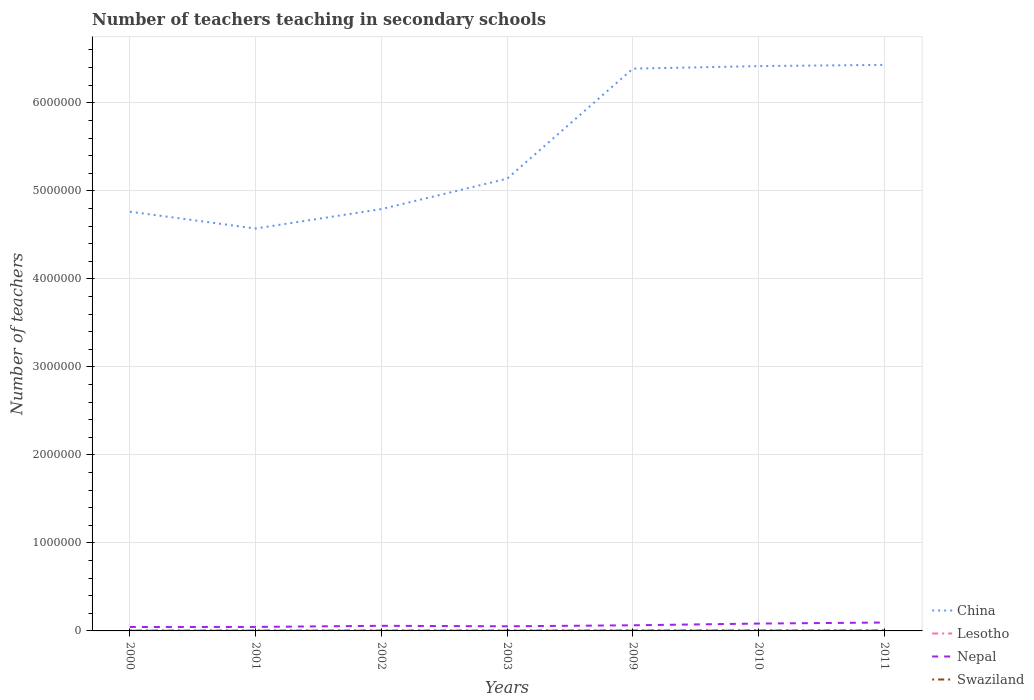How many different coloured lines are there?
Ensure brevity in your answer.  4. Across all years, what is the maximum number of teachers teaching in secondary schools in Lesotho?
Offer a very short reply. 3368. In which year was the number of teachers teaching in secondary schools in Swaziland maximum?
Keep it short and to the point. 2000. What is the total number of teachers teaching in secondary schools in Swaziland in the graph?
Make the answer very short. -1045. What is the difference between the highest and the second highest number of teachers teaching in secondary schools in China?
Your response must be concise. 1.86e+06. Is the number of teachers teaching in secondary schools in Lesotho strictly greater than the number of teachers teaching in secondary schools in China over the years?
Your answer should be very brief. Yes. What is the difference between two consecutive major ticks on the Y-axis?
Keep it short and to the point. 1.00e+06. Are the values on the major ticks of Y-axis written in scientific E-notation?
Give a very brief answer. No. Does the graph contain any zero values?
Keep it short and to the point. No. Where does the legend appear in the graph?
Your answer should be very brief. Bottom right. How many legend labels are there?
Offer a very short reply. 4. What is the title of the graph?
Make the answer very short. Number of teachers teaching in secondary schools. What is the label or title of the Y-axis?
Your response must be concise. Number of teachers. What is the Number of teachers in China in 2000?
Your answer should be compact. 4.76e+06. What is the Number of teachers of Lesotho in 2000?
Your answer should be very brief. 3368. What is the Number of teachers of Nepal in 2000?
Your response must be concise. 4.46e+04. What is the Number of teachers in Swaziland in 2000?
Ensure brevity in your answer.  3487. What is the Number of teachers in China in 2001?
Provide a short and direct response. 4.57e+06. What is the Number of teachers in Lesotho in 2001?
Provide a short and direct response. 3455. What is the Number of teachers in Nepal in 2001?
Provide a short and direct response. 4.54e+04. What is the Number of teachers of Swaziland in 2001?
Give a very brief answer. 3647. What is the Number of teachers in China in 2002?
Keep it short and to the point. 4.79e+06. What is the Number of teachers of Lesotho in 2002?
Your answer should be very brief. 3546. What is the Number of teachers of Nepal in 2002?
Make the answer very short. 5.82e+04. What is the Number of teachers of Swaziland in 2002?
Your answer should be compact. 3845. What is the Number of teachers of China in 2003?
Provide a succinct answer. 5.14e+06. What is the Number of teachers in Lesotho in 2003?
Give a very brief answer. 3636. What is the Number of teachers in Nepal in 2003?
Make the answer very short. 5.25e+04. What is the Number of teachers in Swaziland in 2003?
Ensure brevity in your answer.  3684. What is the Number of teachers of China in 2009?
Provide a short and direct response. 6.39e+06. What is the Number of teachers in Lesotho in 2009?
Ensure brevity in your answer.  4962. What is the Number of teachers of Nepal in 2009?
Provide a succinct answer. 6.40e+04. What is the Number of teachers in Swaziland in 2009?
Your answer should be compact. 4717. What is the Number of teachers of China in 2010?
Ensure brevity in your answer.  6.42e+06. What is the Number of teachers of Lesotho in 2010?
Ensure brevity in your answer.  5139. What is the Number of teachers in Nepal in 2010?
Keep it short and to the point. 8.36e+04. What is the Number of teachers in Swaziland in 2010?
Ensure brevity in your answer.  4890. What is the Number of teachers of China in 2011?
Ensure brevity in your answer.  6.43e+06. What is the Number of teachers in Lesotho in 2011?
Your answer should be compact. 5282. What is the Number of teachers of Nepal in 2011?
Offer a very short reply. 9.53e+04. What is the Number of teachers of Swaziland in 2011?
Offer a terse response. 5250. Across all years, what is the maximum Number of teachers in China?
Offer a very short reply. 6.43e+06. Across all years, what is the maximum Number of teachers of Lesotho?
Keep it short and to the point. 5282. Across all years, what is the maximum Number of teachers in Nepal?
Offer a very short reply. 9.53e+04. Across all years, what is the maximum Number of teachers in Swaziland?
Ensure brevity in your answer.  5250. Across all years, what is the minimum Number of teachers of China?
Provide a succinct answer. 4.57e+06. Across all years, what is the minimum Number of teachers of Lesotho?
Ensure brevity in your answer.  3368. Across all years, what is the minimum Number of teachers of Nepal?
Keep it short and to the point. 4.46e+04. Across all years, what is the minimum Number of teachers in Swaziland?
Ensure brevity in your answer.  3487. What is the total Number of teachers of China in the graph?
Offer a very short reply. 3.85e+07. What is the total Number of teachers in Lesotho in the graph?
Offer a terse response. 2.94e+04. What is the total Number of teachers of Nepal in the graph?
Offer a very short reply. 4.44e+05. What is the total Number of teachers in Swaziland in the graph?
Your answer should be compact. 2.95e+04. What is the difference between the Number of teachers in China in 2000 and that in 2001?
Offer a very short reply. 1.91e+05. What is the difference between the Number of teachers in Lesotho in 2000 and that in 2001?
Provide a short and direct response. -87. What is the difference between the Number of teachers of Nepal in 2000 and that in 2001?
Offer a terse response. -753. What is the difference between the Number of teachers of Swaziland in 2000 and that in 2001?
Offer a very short reply. -160. What is the difference between the Number of teachers in China in 2000 and that in 2002?
Offer a terse response. -2.98e+04. What is the difference between the Number of teachers in Lesotho in 2000 and that in 2002?
Keep it short and to the point. -178. What is the difference between the Number of teachers in Nepal in 2000 and that in 2002?
Offer a terse response. -1.36e+04. What is the difference between the Number of teachers of Swaziland in 2000 and that in 2002?
Ensure brevity in your answer.  -358. What is the difference between the Number of teachers of China in 2000 and that in 2003?
Your response must be concise. -3.75e+05. What is the difference between the Number of teachers in Lesotho in 2000 and that in 2003?
Your answer should be very brief. -268. What is the difference between the Number of teachers of Nepal in 2000 and that in 2003?
Keep it short and to the point. -7908. What is the difference between the Number of teachers in Swaziland in 2000 and that in 2003?
Provide a succinct answer. -197. What is the difference between the Number of teachers in China in 2000 and that in 2009?
Give a very brief answer. -1.63e+06. What is the difference between the Number of teachers in Lesotho in 2000 and that in 2009?
Your response must be concise. -1594. What is the difference between the Number of teachers of Nepal in 2000 and that in 2009?
Offer a terse response. -1.94e+04. What is the difference between the Number of teachers of Swaziland in 2000 and that in 2009?
Make the answer very short. -1230. What is the difference between the Number of teachers of China in 2000 and that in 2010?
Keep it short and to the point. -1.65e+06. What is the difference between the Number of teachers of Lesotho in 2000 and that in 2010?
Offer a very short reply. -1771. What is the difference between the Number of teachers in Nepal in 2000 and that in 2010?
Make the answer very short. -3.90e+04. What is the difference between the Number of teachers in Swaziland in 2000 and that in 2010?
Keep it short and to the point. -1403. What is the difference between the Number of teachers in China in 2000 and that in 2011?
Your answer should be compact. -1.67e+06. What is the difference between the Number of teachers in Lesotho in 2000 and that in 2011?
Keep it short and to the point. -1914. What is the difference between the Number of teachers in Nepal in 2000 and that in 2011?
Offer a terse response. -5.07e+04. What is the difference between the Number of teachers of Swaziland in 2000 and that in 2011?
Give a very brief answer. -1763. What is the difference between the Number of teachers in China in 2001 and that in 2002?
Provide a short and direct response. -2.21e+05. What is the difference between the Number of teachers in Lesotho in 2001 and that in 2002?
Your answer should be compact. -91. What is the difference between the Number of teachers of Nepal in 2001 and that in 2002?
Provide a short and direct response. -1.28e+04. What is the difference between the Number of teachers in Swaziland in 2001 and that in 2002?
Provide a short and direct response. -198. What is the difference between the Number of teachers in China in 2001 and that in 2003?
Ensure brevity in your answer.  -5.66e+05. What is the difference between the Number of teachers of Lesotho in 2001 and that in 2003?
Offer a very short reply. -181. What is the difference between the Number of teachers of Nepal in 2001 and that in 2003?
Your response must be concise. -7155. What is the difference between the Number of teachers of Swaziland in 2001 and that in 2003?
Your response must be concise. -37. What is the difference between the Number of teachers in China in 2001 and that in 2009?
Ensure brevity in your answer.  -1.82e+06. What is the difference between the Number of teachers in Lesotho in 2001 and that in 2009?
Your answer should be compact. -1507. What is the difference between the Number of teachers in Nepal in 2001 and that in 2009?
Make the answer very short. -1.86e+04. What is the difference between the Number of teachers in Swaziland in 2001 and that in 2009?
Provide a succinct answer. -1070. What is the difference between the Number of teachers of China in 2001 and that in 2010?
Your answer should be very brief. -1.84e+06. What is the difference between the Number of teachers of Lesotho in 2001 and that in 2010?
Provide a succinct answer. -1684. What is the difference between the Number of teachers in Nepal in 2001 and that in 2010?
Ensure brevity in your answer.  -3.83e+04. What is the difference between the Number of teachers of Swaziland in 2001 and that in 2010?
Your answer should be compact. -1243. What is the difference between the Number of teachers in China in 2001 and that in 2011?
Give a very brief answer. -1.86e+06. What is the difference between the Number of teachers in Lesotho in 2001 and that in 2011?
Provide a succinct answer. -1827. What is the difference between the Number of teachers in Nepal in 2001 and that in 2011?
Ensure brevity in your answer.  -4.99e+04. What is the difference between the Number of teachers in Swaziland in 2001 and that in 2011?
Your answer should be compact. -1603. What is the difference between the Number of teachers of China in 2002 and that in 2003?
Your response must be concise. -3.45e+05. What is the difference between the Number of teachers of Lesotho in 2002 and that in 2003?
Ensure brevity in your answer.  -90. What is the difference between the Number of teachers of Nepal in 2002 and that in 2003?
Make the answer very short. 5662. What is the difference between the Number of teachers of Swaziland in 2002 and that in 2003?
Offer a very short reply. 161. What is the difference between the Number of teachers in China in 2002 and that in 2009?
Offer a terse response. -1.60e+06. What is the difference between the Number of teachers of Lesotho in 2002 and that in 2009?
Keep it short and to the point. -1416. What is the difference between the Number of teachers of Nepal in 2002 and that in 2009?
Offer a very short reply. -5803. What is the difference between the Number of teachers in Swaziland in 2002 and that in 2009?
Keep it short and to the point. -872. What is the difference between the Number of teachers in China in 2002 and that in 2010?
Your response must be concise. -1.62e+06. What is the difference between the Number of teachers of Lesotho in 2002 and that in 2010?
Provide a succinct answer. -1593. What is the difference between the Number of teachers of Nepal in 2002 and that in 2010?
Ensure brevity in your answer.  -2.54e+04. What is the difference between the Number of teachers of Swaziland in 2002 and that in 2010?
Your answer should be very brief. -1045. What is the difference between the Number of teachers in China in 2002 and that in 2011?
Make the answer very short. -1.64e+06. What is the difference between the Number of teachers of Lesotho in 2002 and that in 2011?
Ensure brevity in your answer.  -1736. What is the difference between the Number of teachers in Nepal in 2002 and that in 2011?
Give a very brief answer. -3.71e+04. What is the difference between the Number of teachers in Swaziland in 2002 and that in 2011?
Ensure brevity in your answer.  -1405. What is the difference between the Number of teachers in China in 2003 and that in 2009?
Your answer should be compact. -1.25e+06. What is the difference between the Number of teachers in Lesotho in 2003 and that in 2009?
Your answer should be compact. -1326. What is the difference between the Number of teachers in Nepal in 2003 and that in 2009?
Offer a terse response. -1.15e+04. What is the difference between the Number of teachers in Swaziland in 2003 and that in 2009?
Offer a terse response. -1033. What is the difference between the Number of teachers in China in 2003 and that in 2010?
Provide a short and direct response. -1.28e+06. What is the difference between the Number of teachers of Lesotho in 2003 and that in 2010?
Keep it short and to the point. -1503. What is the difference between the Number of teachers of Nepal in 2003 and that in 2010?
Keep it short and to the point. -3.11e+04. What is the difference between the Number of teachers of Swaziland in 2003 and that in 2010?
Make the answer very short. -1206. What is the difference between the Number of teachers of China in 2003 and that in 2011?
Your response must be concise. -1.29e+06. What is the difference between the Number of teachers of Lesotho in 2003 and that in 2011?
Provide a short and direct response. -1646. What is the difference between the Number of teachers of Nepal in 2003 and that in 2011?
Provide a short and direct response. -4.28e+04. What is the difference between the Number of teachers in Swaziland in 2003 and that in 2011?
Ensure brevity in your answer.  -1566. What is the difference between the Number of teachers in China in 2009 and that in 2010?
Make the answer very short. -2.87e+04. What is the difference between the Number of teachers in Lesotho in 2009 and that in 2010?
Make the answer very short. -177. What is the difference between the Number of teachers in Nepal in 2009 and that in 2010?
Provide a short and direct response. -1.96e+04. What is the difference between the Number of teachers of Swaziland in 2009 and that in 2010?
Provide a succinct answer. -173. What is the difference between the Number of teachers of China in 2009 and that in 2011?
Give a very brief answer. -4.28e+04. What is the difference between the Number of teachers in Lesotho in 2009 and that in 2011?
Offer a very short reply. -320. What is the difference between the Number of teachers in Nepal in 2009 and that in 2011?
Provide a short and direct response. -3.13e+04. What is the difference between the Number of teachers in Swaziland in 2009 and that in 2011?
Ensure brevity in your answer.  -533. What is the difference between the Number of teachers in China in 2010 and that in 2011?
Your response must be concise. -1.41e+04. What is the difference between the Number of teachers of Lesotho in 2010 and that in 2011?
Your answer should be compact. -143. What is the difference between the Number of teachers of Nepal in 2010 and that in 2011?
Offer a very short reply. -1.17e+04. What is the difference between the Number of teachers in Swaziland in 2010 and that in 2011?
Your answer should be very brief. -360. What is the difference between the Number of teachers of China in 2000 and the Number of teachers of Lesotho in 2001?
Make the answer very short. 4.76e+06. What is the difference between the Number of teachers in China in 2000 and the Number of teachers in Nepal in 2001?
Provide a short and direct response. 4.72e+06. What is the difference between the Number of teachers in China in 2000 and the Number of teachers in Swaziland in 2001?
Your answer should be very brief. 4.76e+06. What is the difference between the Number of teachers in Lesotho in 2000 and the Number of teachers in Nepal in 2001?
Ensure brevity in your answer.  -4.20e+04. What is the difference between the Number of teachers of Lesotho in 2000 and the Number of teachers of Swaziland in 2001?
Ensure brevity in your answer.  -279. What is the difference between the Number of teachers of Nepal in 2000 and the Number of teachers of Swaziland in 2001?
Make the answer very short. 4.10e+04. What is the difference between the Number of teachers of China in 2000 and the Number of teachers of Lesotho in 2002?
Make the answer very short. 4.76e+06. What is the difference between the Number of teachers in China in 2000 and the Number of teachers in Nepal in 2002?
Offer a terse response. 4.70e+06. What is the difference between the Number of teachers in China in 2000 and the Number of teachers in Swaziland in 2002?
Ensure brevity in your answer.  4.76e+06. What is the difference between the Number of teachers of Lesotho in 2000 and the Number of teachers of Nepal in 2002?
Make the answer very short. -5.48e+04. What is the difference between the Number of teachers of Lesotho in 2000 and the Number of teachers of Swaziland in 2002?
Provide a succinct answer. -477. What is the difference between the Number of teachers in Nepal in 2000 and the Number of teachers in Swaziland in 2002?
Offer a terse response. 4.08e+04. What is the difference between the Number of teachers of China in 2000 and the Number of teachers of Lesotho in 2003?
Your response must be concise. 4.76e+06. What is the difference between the Number of teachers in China in 2000 and the Number of teachers in Nepal in 2003?
Provide a short and direct response. 4.71e+06. What is the difference between the Number of teachers of China in 2000 and the Number of teachers of Swaziland in 2003?
Your response must be concise. 4.76e+06. What is the difference between the Number of teachers in Lesotho in 2000 and the Number of teachers in Nepal in 2003?
Provide a short and direct response. -4.92e+04. What is the difference between the Number of teachers in Lesotho in 2000 and the Number of teachers in Swaziland in 2003?
Keep it short and to the point. -316. What is the difference between the Number of teachers of Nepal in 2000 and the Number of teachers of Swaziland in 2003?
Make the answer very short. 4.09e+04. What is the difference between the Number of teachers of China in 2000 and the Number of teachers of Lesotho in 2009?
Make the answer very short. 4.76e+06. What is the difference between the Number of teachers of China in 2000 and the Number of teachers of Nepal in 2009?
Provide a short and direct response. 4.70e+06. What is the difference between the Number of teachers in China in 2000 and the Number of teachers in Swaziland in 2009?
Keep it short and to the point. 4.76e+06. What is the difference between the Number of teachers of Lesotho in 2000 and the Number of teachers of Nepal in 2009?
Your answer should be very brief. -6.06e+04. What is the difference between the Number of teachers in Lesotho in 2000 and the Number of teachers in Swaziland in 2009?
Your answer should be compact. -1349. What is the difference between the Number of teachers of Nepal in 2000 and the Number of teachers of Swaziland in 2009?
Give a very brief answer. 3.99e+04. What is the difference between the Number of teachers of China in 2000 and the Number of teachers of Lesotho in 2010?
Provide a short and direct response. 4.76e+06. What is the difference between the Number of teachers of China in 2000 and the Number of teachers of Nepal in 2010?
Provide a short and direct response. 4.68e+06. What is the difference between the Number of teachers in China in 2000 and the Number of teachers in Swaziland in 2010?
Provide a short and direct response. 4.76e+06. What is the difference between the Number of teachers of Lesotho in 2000 and the Number of teachers of Nepal in 2010?
Your answer should be very brief. -8.03e+04. What is the difference between the Number of teachers in Lesotho in 2000 and the Number of teachers in Swaziland in 2010?
Your response must be concise. -1522. What is the difference between the Number of teachers in Nepal in 2000 and the Number of teachers in Swaziland in 2010?
Your answer should be compact. 3.97e+04. What is the difference between the Number of teachers of China in 2000 and the Number of teachers of Lesotho in 2011?
Make the answer very short. 4.76e+06. What is the difference between the Number of teachers of China in 2000 and the Number of teachers of Nepal in 2011?
Give a very brief answer. 4.67e+06. What is the difference between the Number of teachers in China in 2000 and the Number of teachers in Swaziland in 2011?
Your answer should be very brief. 4.76e+06. What is the difference between the Number of teachers in Lesotho in 2000 and the Number of teachers in Nepal in 2011?
Provide a succinct answer. -9.19e+04. What is the difference between the Number of teachers of Lesotho in 2000 and the Number of teachers of Swaziland in 2011?
Offer a very short reply. -1882. What is the difference between the Number of teachers in Nepal in 2000 and the Number of teachers in Swaziland in 2011?
Give a very brief answer. 3.94e+04. What is the difference between the Number of teachers of China in 2001 and the Number of teachers of Lesotho in 2002?
Your answer should be compact. 4.57e+06. What is the difference between the Number of teachers of China in 2001 and the Number of teachers of Nepal in 2002?
Offer a very short reply. 4.51e+06. What is the difference between the Number of teachers of China in 2001 and the Number of teachers of Swaziland in 2002?
Give a very brief answer. 4.57e+06. What is the difference between the Number of teachers of Lesotho in 2001 and the Number of teachers of Nepal in 2002?
Your answer should be very brief. -5.47e+04. What is the difference between the Number of teachers of Lesotho in 2001 and the Number of teachers of Swaziland in 2002?
Give a very brief answer. -390. What is the difference between the Number of teachers in Nepal in 2001 and the Number of teachers in Swaziland in 2002?
Your response must be concise. 4.15e+04. What is the difference between the Number of teachers in China in 2001 and the Number of teachers in Lesotho in 2003?
Your answer should be very brief. 4.57e+06. What is the difference between the Number of teachers in China in 2001 and the Number of teachers in Nepal in 2003?
Offer a very short reply. 4.52e+06. What is the difference between the Number of teachers of China in 2001 and the Number of teachers of Swaziland in 2003?
Provide a short and direct response. 4.57e+06. What is the difference between the Number of teachers in Lesotho in 2001 and the Number of teachers in Nepal in 2003?
Offer a very short reply. -4.91e+04. What is the difference between the Number of teachers in Lesotho in 2001 and the Number of teachers in Swaziland in 2003?
Your response must be concise. -229. What is the difference between the Number of teachers of Nepal in 2001 and the Number of teachers of Swaziland in 2003?
Keep it short and to the point. 4.17e+04. What is the difference between the Number of teachers in China in 2001 and the Number of teachers in Lesotho in 2009?
Your answer should be compact. 4.57e+06. What is the difference between the Number of teachers in China in 2001 and the Number of teachers in Nepal in 2009?
Provide a succinct answer. 4.51e+06. What is the difference between the Number of teachers of China in 2001 and the Number of teachers of Swaziland in 2009?
Provide a succinct answer. 4.57e+06. What is the difference between the Number of teachers in Lesotho in 2001 and the Number of teachers in Nepal in 2009?
Keep it short and to the point. -6.05e+04. What is the difference between the Number of teachers of Lesotho in 2001 and the Number of teachers of Swaziland in 2009?
Offer a terse response. -1262. What is the difference between the Number of teachers in Nepal in 2001 and the Number of teachers in Swaziland in 2009?
Provide a short and direct response. 4.07e+04. What is the difference between the Number of teachers in China in 2001 and the Number of teachers in Lesotho in 2010?
Your answer should be very brief. 4.57e+06. What is the difference between the Number of teachers in China in 2001 and the Number of teachers in Nepal in 2010?
Your answer should be very brief. 4.49e+06. What is the difference between the Number of teachers in China in 2001 and the Number of teachers in Swaziland in 2010?
Offer a terse response. 4.57e+06. What is the difference between the Number of teachers in Lesotho in 2001 and the Number of teachers in Nepal in 2010?
Provide a short and direct response. -8.02e+04. What is the difference between the Number of teachers in Lesotho in 2001 and the Number of teachers in Swaziland in 2010?
Give a very brief answer. -1435. What is the difference between the Number of teachers in Nepal in 2001 and the Number of teachers in Swaziland in 2010?
Ensure brevity in your answer.  4.05e+04. What is the difference between the Number of teachers of China in 2001 and the Number of teachers of Lesotho in 2011?
Your answer should be very brief. 4.57e+06. What is the difference between the Number of teachers in China in 2001 and the Number of teachers in Nepal in 2011?
Provide a succinct answer. 4.48e+06. What is the difference between the Number of teachers of China in 2001 and the Number of teachers of Swaziland in 2011?
Keep it short and to the point. 4.57e+06. What is the difference between the Number of teachers in Lesotho in 2001 and the Number of teachers in Nepal in 2011?
Your response must be concise. -9.18e+04. What is the difference between the Number of teachers of Lesotho in 2001 and the Number of teachers of Swaziland in 2011?
Offer a terse response. -1795. What is the difference between the Number of teachers of Nepal in 2001 and the Number of teachers of Swaziland in 2011?
Your answer should be very brief. 4.01e+04. What is the difference between the Number of teachers of China in 2002 and the Number of teachers of Lesotho in 2003?
Your response must be concise. 4.79e+06. What is the difference between the Number of teachers of China in 2002 and the Number of teachers of Nepal in 2003?
Provide a succinct answer. 4.74e+06. What is the difference between the Number of teachers in China in 2002 and the Number of teachers in Swaziland in 2003?
Your answer should be very brief. 4.79e+06. What is the difference between the Number of teachers of Lesotho in 2002 and the Number of teachers of Nepal in 2003?
Your response must be concise. -4.90e+04. What is the difference between the Number of teachers of Lesotho in 2002 and the Number of teachers of Swaziland in 2003?
Give a very brief answer. -138. What is the difference between the Number of teachers of Nepal in 2002 and the Number of teachers of Swaziland in 2003?
Your answer should be compact. 5.45e+04. What is the difference between the Number of teachers in China in 2002 and the Number of teachers in Lesotho in 2009?
Your answer should be very brief. 4.79e+06. What is the difference between the Number of teachers in China in 2002 and the Number of teachers in Nepal in 2009?
Your answer should be compact. 4.73e+06. What is the difference between the Number of teachers of China in 2002 and the Number of teachers of Swaziland in 2009?
Give a very brief answer. 4.79e+06. What is the difference between the Number of teachers of Lesotho in 2002 and the Number of teachers of Nepal in 2009?
Your response must be concise. -6.04e+04. What is the difference between the Number of teachers in Lesotho in 2002 and the Number of teachers in Swaziland in 2009?
Keep it short and to the point. -1171. What is the difference between the Number of teachers of Nepal in 2002 and the Number of teachers of Swaziland in 2009?
Provide a succinct answer. 5.35e+04. What is the difference between the Number of teachers in China in 2002 and the Number of teachers in Lesotho in 2010?
Provide a short and direct response. 4.79e+06. What is the difference between the Number of teachers in China in 2002 and the Number of teachers in Nepal in 2010?
Offer a terse response. 4.71e+06. What is the difference between the Number of teachers in China in 2002 and the Number of teachers in Swaziland in 2010?
Keep it short and to the point. 4.79e+06. What is the difference between the Number of teachers of Lesotho in 2002 and the Number of teachers of Nepal in 2010?
Ensure brevity in your answer.  -8.01e+04. What is the difference between the Number of teachers in Lesotho in 2002 and the Number of teachers in Swaziland in 2010?
Keep it short and to the point. -1344. What is the difference between the Number of teachers of Nepal in 2002 and the Number of teachers of Swaziland in 2010?
Keep it short and to the point. 5.33e+04. What is the difference between the Number of teachers in China in 2002 and the Number of teachers in Lesotho in 2011?
Your answer should be very brief. 4.79e+06. What is the difference between the Number of teachers of China in 2002 and the Number of teachers of Nepal in 2011?
Make the answer very short. 4.70e+06. What is the difference between the Number of teachers of China in 2002 and the Number of teachers of Swaziland in 2011?
Your answer should be very brief. 4.79e+06. What is the difference between the Number of teachers in Lesotho in 2002 and the Number of teachers in Nepal in 2011?
Ensure brevity in your answer.  -9.17e+04. What is the difference between the Number of teachers in Lesotho in 2002 and the Number of teachers in Swaziland in 2011?
Your answer should be compact. -1704. What is the difference between the Number of teachers in Nepal in 2002 and the Number of teachers in Swaziland in 2011?
Keep it short and to the point. 5.29e+04. What is the difference between the Number of teachers of China in 2003 and the Number of teachers of Lesotho in 2009?
Provide a short and direct response. 5.13e+06. What is the difference between the Number of teachers of China in 2003 and the Number of teachers of Nepal in 2009?
Provide a short and direct response. 5.07e+06. What is the difference between the Number of teachers in China in 2003 and the Number of teachers in Swaziland in 2009?
Provide a succinct answer. 5.13e+06. What is the difference between the Number of teachers of Lesotho in 2003 and the Number of teachers of Nepal in 2009?
Make the answer very short. -6.04e+04. What is the difference between the Number of teachers of Lesotho in 2003 and the Number of teachers of Swaziland in 2009?
Keep it short and to the point. -1081. What is the difference between the Number of teachers of Nepal in 2003 and the Number of teachers of Swaziland in 2009?
Make the answer very short. 4.78e+04. What is the difference between the Number of teachers in China in 2003 and the Number of teachers in Lesotho in 2010?
Provide a succinct answer. 5.13e+06. What is the difference between the Number of teachers in China in 2003 and the Number of teachers in Nepal in 2010?
Ensure brevity in your answer.  5.05e+06. What is the difference between the Number of teachers of China in 2003 and the Number of teachers of Swaziland in 2010?
Your answer should be very brief. 5.13e+06. What is the difference between the Number of teachers in Lesotho in 2003 and the Number of teachers in Nepal in 2010?
Your answer should be very brief. -8.00e+04. What is the difference between the Number of teachers of Lesotho in 2003 and the Number of teachers of Swaziland in 2010?
Make the answer very short. -1254. What is the difference between the Number of teachers in Nepal in 2003 and the Number of teachers in Swaziland in 2010?
Keep it short and to the point. 4.76e+04. What is the difference between the Number of teachers in China in 2003 and the Number of teachers in Lesotho in 2011?
Give a very brief answer. 5.13e+06. What is the difference between the Number of teachers of China in 2003 and the Number of teachers of Nepal in 2011?
Give a very brief answer. 5.04e+06. What is the difference between the Number of teachers of China in 2003 and the Number of teachers of Swaziland in 2011?
Your answer should be very brief. 5.13e+06. What is the difference between the Number of teachers in Lesotho in 2003 and the Number of teachers in Nepal in 2011?
Your response must be concise. -9.17e+04. What is the difference between the Number of teachers in Lesotho in 2003 and the Number of teachers in Swaziland in 2011?
Provide a succinct answer. -1614. What is the difference between the Number of teachers in Nepal in 2003 and the Number of teachers in Swaziland in 2011?
Keep it short and to the point. 4.73e+04. What is the difference between the Number of teachers in China in 2009 and the Number of teachers in Lesotho in 2010?
Your answer should be compact. 6.38e+06. What is the difference between the Number of teachers of China in 2009 and the Number of teachers of Nepal in 2010?
Keep it short and to the point. 6.30e+06. What is the difference between the Number of teachers in China in 2009 and the Number of teachers in Swaziland in 2010?
Your answer should be very brief. 6.38e+06. What is the difference between the Number of teachers in Lesotho in 2009 and the Number of teachers in Nepal in 2010?
Keep it short and to the point. -7.87e+04. What is the difference between the Number of teachers of Nepal in 2009 and the Number of teachers of Swaziland in 2010?
Make the answer very short. 5.91e+04. What is the difference between the Number of teachers in China in 2009 and the Number of teachers in Lesotho in 2011?
Make the answer very short. 6.38e+06. What is the difference between the Number of teachers of China in 2009 and the Number of teachers of Nepal in 2011?
Offer a very short reply. 6.29e+06. What is the difference between the Number of teachers of China in 2009 and the Number of teachers of Swaziland in 2011?
Provide a short and direct response. 6.38e+06. What is the difference between the Number of teachers of Lesotho in 2009 and the Number of teachers of Nepal in 2011?
Ensure brevity in your answer.  -9.03e+04. What is the difference between the Number of teachers in Lesotho in 2009 and the Number of teachers in Swaziland in 2011?
Provide a short and direct response. -288. What is the difference between the Number of teachers of Nepal in 2009 and the Number of teachers of Swaziland in 2011?
Offer a very short reply. 5.87e+04. What is the difference between the Number of teachers of China in 2010 and the Number of teachers of Lesotho in 2011?
Provide a succinct answer. 6.41e+06. What is the difference between the Number of teachers of China in 2010 and the Number of teachers of Nepal in 2011?
Your response must be concise. 6.32e+06. What is the difference between the Number of teachers of China in 2010 and the Number of teachers of Swaziland in 2011?
Ensure brevity in your answer.  6.41e+06. What is the difference between the Number of teachers of Lesotho in 2010 and the Number of teachers of Nepal in 2011?
Give a very brief answer. -9.02e+04. What is the difference between the Number of teachers in Lesotho in 2010 and the Number of teachers in Swaziland in 2011?
Provide a succinct answer. -111. What is the difference between the Number of teachers in Nepal in 2010 and the Number of teachers in Swaziland in 2011?
Make the answer very short. 7.84e+04. What is the average Number of teachers of China per year?
Make the answer very short. 5.50e+06. What is the average Number of teachers of Lesotho per year?
Provide a short and direct response. 4198.29. What is the average Number of teachers of Nepal per year?
Give a very brief answer. 6.34e+04. What is the average Number of teachers in Swaziland per year?
Provide a succinct answer. 4217.14. In the year 2000, what is the difference between the Number of teachers in China and Number of teachers in Lesotho?
Your answer should be very brief. 4.76e+06. In the year 2000, what is the difference between the Number of teachers of China and Number of teachers of Nepal?
Your response must be concise. 4.72e+06. In the year 2000, what is the difference between the Number of teachers of China and Number of teachers of Swaziland?
Ensure brevity in your answer.  4.76e+06. In the year 2000, what is the difference between the Number of teachers in Lesotho and Number of teachers in Nepal?
Provide a succinct answer. -4.13e+04. In the year 2000, what is the difference between the Number of teachers of Lesotho and Number of teachers of Swaziland?
Your response must be concise. -119. In the year 2000, what is the difference between the Number of teachers in Nepal and Number of teachers in Swaziland?
Offer a terse response. 4.11e+04. In the year 2001, what is the difference between the Number of teachers in China and Number of teachers in Lesotho?
Your answer should be very brief. 4.57e+06. In the year 2001, what is the difference between the Number of teachers in China and Number of teachers in Nepal?
Keep it short and to the point. 4.53e+06. In the year 2001, what is the difference between the Number of teachers in China and Number of teachers in Swaziland?
Offer a terse response. 4.57e+06. In the year 2001, what is the difference between the Number of teachers of Lesotho and Number of teachers of Nepal?
Keep it short and to the point. -4.19e+04. In the year 2001, what is the difference between the Number of teachers in Lesotho and Number of teachers in Swaziland?
Make the answer very short. -192. In the year 2001, what is the difference between the Number of teachers of Nepal and Number of teachers of Swaziland?
Give a very brief answer. 4.17e+04. In the year 2002, what is the difference between the Number of teachers of China and Number of teachers of Lesotho?
Your answer should be very brief. 4.79e+06. In the year 2002, what is the difference between the Number of teachers in China and Number of teachers in Nepal?
Ensure brevity in your answer.  4.73e+06. In the year 2002, what is the difference between the Number of teachers of China and Number of teachers of Swaziland?
Provide a succinct answer. 4.79e+06. In the year 2002, what is the difference between the Number of teachers in Lesotho and Number of teachers in Nepal?
Give a very brief answer. -5.46e+04. In the year 2002, what is the difference between the Number of teachers of Lesotho and Number of teachers of Swaziland?
Provide a succinct answer. -299. In the year 2002, what is the difference between the Number of teachers in Nepal and Number of teachers in Swaziland?
Keep it short and to the point. 5.43e+04. In the year 2003, what is the difference between the Number of teachers in China and Number of teachers in Lesotho?
Your answer should be very brief. 5.13e+06. In the year 2003, what is the difference between the Number of teachers in China and Number of teachers in Nepal?
Your response must be concise. 5.09e+06. In the year 2003, what is the difference between the Number of teachers of China and Number of teachers of Swaziland?
Offer a very short reply. 5.13e+06. In the year 2003, what is the difference between the Number of teachers of Lesotho and Number of teachers of Nepal?
Give a very brief answer. -4.89e+04. In the year 2003, what is the difference between the Number of teachers of Lesotho and Number of teachers of Swaziland?
Offer a very short reply. -48. In the year 2003, what is the difference between the Number of teachers in Nepal and Number of teachers in Swaziland?
Give a very brief answer. 4.88e+04. In the year 2009, what is the difference between the Number of teachers in China and Number of teachers in Lesotho?
Offer a terse response. 6.38e+06. In the year 2009, what is the difference between the Number of teachers in China and Number of teachers in Nepal?
Offer a very short reply. 6.32e+06. In the year 2009, what is the difference between the Number of teachers in China and Number of teachers in Swaziland?
Make the answer very short. 6.38e+06. In the year 2009, what is the difference between the Number of teachers of Lesotho and Number of teachers of Nepal?
Your answer should be compact. -5.90e+04. In the year 2009, what is the difference between the Number of teachers in Lesotho and Number of teachers in Swaziland?
Your response must be concise. 245. In the year 2009, what is the difference between the Number of teachers of Nepal and Number of teachers of Swaziland?
Provide a short and direct response. 5.93e+04. In the year 2010, what is the difference between the Number of teachers of China and Number of teachers of Lesotho?
Your answer should be very brief. 6.41e+06. In the year 2010, what is the difference between the Number of teachers of China and Number of teachers of Nepal?
Offer a terse response. 6.33e+06. In the year 2010, what is the difference between the Number of teachers of China and Number of teachers of Swaziland?
Your answer should be compact. 6.41e+06. In the year 2010, what is the difference between the Number of teachers in Lesotho and Number of teachers in Nepal?
Your answer should be compact. -7.85e+04. In the year 2010, what is the difference between the Number of teachers in Lesotho and Number of teachers in Swaziland?
Make the answer very short. 249. In the year 2010, what is the difference between the Number of teachers in Nepal and Number of teachers in Swaziland?
Offer a terse response. 7.87e+04. In the year 2011, what is the difference between the Number of teachers of China and Number of teachers of Lesotho?
Provide a succinct answer. 6.43e+06. In the year 2011, what is the difference between the Number of teachers in China and Number of teachers in Nepal?
Provide a short and direct response. 6.34e+06. In the year 2011, what is the difference between the Number of teachers in China and Number of teachers in Swaziland?
Give a very brief answer. 6.43e+06. In the year 2011, what is the difference between the Number of teachers of Lesotho and Number of teachers of Nepal?
Offer a very short reply. -9.00e+04. In the year 2011, what is the difference between the Number of teachers in Lesotho and Number of teachers in Swaziland?
Your response must be concise. 32. In the year 2011, what is the difference between the Number of teachers of Nepal and Number of teachers of Swaziland?
Provide a short and direct response. 9.00e+04. What is the ratio of the Number of teachers in China in 2000 to that in 2001?
Your response must be concise. 1.04. What is the ratio of the Number of teachers of Lesotho in 2000 to that in 2001?
Give a very brief answer. 0.97. What is the ratio of the Number of teachers of Nepal in 2000 to that in 2001?
Give a very brief answer. 0.98. What is the ratio of the Number of teachers in Swaziland in 2000 to that in 2001?
Provide a short and direct response. 0.96. What is the ratio of the Number of teachers in China in 2000 to that in 2002?
Your response must be concise. 0.99. What is the ratio of the Number of teachers in Lesotho in 2000 to that in 2002?
Your response must be concise. 0.95. What is the ratio of the Number of teachers in Nepal in 2000 to that in 2002?
Your answer should be very brief. 0.77. What is the ratio of the Number of teachers in Swaziland in 2000 to that in 2002?
Offer a very short reply. 0.91. What is the ratio of the Number of teachers of China in 2000 to that in 2003?
Provide a short and direct response. 0.93. What is the ratio of the Number of teachers in Lesotho in 2000 to that in 2003?
Provide a short and direct response. 0.93. What is the ratio of the Number of teachers in Nepal in 2000 to that in 2003?
Your answer should be compact. 0.85. What is the ratio of the Number of teachers in Swaziland in 2000 to that in 2003?
Give a very brief answer. 0.95. What is the ratio of the Number of teachers of China in 2000 to that in 2009?
Ensure brevity in your answer.  0.75. What is the ratio of the Number of teachers of Lesotho in 2000 to that in 2009?
Make the answer very short. 0.68. What is the ratio of the Number of teachers in Nepal in 2000 to that in 2009?
Provide a short and direct response. 0.7. What is the ratio of the Number of teachers in Swaziland in 2000 to that in 2009?
Provide a short and direct response. 0.74. What is the ratio of the Number of teachers of China in 2000 to that in 2010?
Your answer should be very brief. 0.74. What is the ratio of the Number of teachers of Lesotho in 2000 to that in 2010?
Provide a short and direct response. 0.66. What is the ratio of the Number of teachers of Nepal in 2000 to that in 2010?
Your answer should be very brief. 0.53. What is the ratio of the Number of teachers in Swaziland in 2000 to that in 2010?
Provide a short and direct response. 0.71. What is the ratio of the Number of teachers of China in 2000 to that in 2011?
Your response must be concise. 0.74. What is the ratio of the Number of teachers of Lesotho in 2000 to that in 2011?
Make the answer very short. 0.64. What is the ratio of the Number of teachers of Nepal in 2000 to that in 2011?
Keep it short and to the point. 0.47. What is the ratio of the Number of teachers in Swaziland in 2000 to that in 2011?
Offer a very short reply. 0.66. What is the ratio of the Number of teachers of China in 2001 to that in 2002?
Offer a terse response. 0.95. What is the ratio of the Number of teachers of Lesotho in 2001 to that in 2002?
Your response must be concise. 0.97. What is the ratio of the Number of teachers in Nepal in 2001 to that in 2002?
Give a very brief answer. 0.78. What is the ratio of the Number of teachers of Swaziland in 2001 to that in 2002?
Give a very brief answer. 0.95. What is the ratio of the Number of teachers in China in 2001 to that in 2003?
Provide a short and direct response. 0.89. What is the ratio of the Number of teachers of Lesotho in 2001 to that in 2003?
Give a very brief answer. 0.95. What is the ratio of the Number of teachers in Nepal in 2001 to that in 2003?
Provide a short and direct response. 0.86. What is the ratio of the Number of teachers in China in 2001 to that in 2009?
Make the answer very short. 0.72. What is the ratio of the Number of teachers of Lesotho in 2001 to that in 2009?
Your response must be concise. 0.7. What is the ratio of the Number of teachers of Nepal in 2001 to that in 2009?
Offer a terse response. 0.71. What is the ratio of the Number of teachers of Swaziland in 2001 to that in 2009?
Your response must be concise. 0.77. What is the ratio of the Number of teachers of China in 2001 to that in 2010?
Give a very brief answer. 0.71. What is the ratio of the Number of teachers of Lesotho in 2001 to that in 2010?
Provide a short and direct response. 0.67. What is the ratio of the Number of teachers in Nepal in 2001 to that in 2010?
Provide a short and direct response. 0.54. What is the ratio of the Number of teachers in Swaziland in 2001 to that in 2010?
Offer a terse response. 0.75. What is the ratio of the Number of teachers in China in 2001 to that in 2011?
Ensure brevity in your answer.  0.71. What is the ratio of the Number of teachers of Lesotho in 2001 to that in 2011?
Your answer should be very brief. 0.65. What is the ratio of the Number of teachers of Nepal in 2001 to that in 2011?
Your response must be concise. 0.48. What is the ratio of the Number of teachers of Swaziland in 2001 to that in 2011?
Ensure brevity in your answer.  0.69. What is the ratio of the Number of teachers in China in 2002 to that in 2003?
Keep it short and to the point. 0.93. What is the ratio of the Number of teachers in Lesotho in 2002 to that in 2003?
Your response must be concise. 0.98. What is the ratio of the Number of teachers in Nepal in 2002 to that in 2003?
Ensure brevity in your answer.  1.11. What is the ratio of the Number of teachers in Swaziland in 2002 to that in 2003?
Your answer should be very brief. 1.04. What is the ratio of the Number of teachers of China in 2002 to that in 2009?
Give a very brief answer. 0.75. What is the ratio of the Number of teachers of Lesotho in 2002 to that in 2009?
Keep it short and to the point. 0.71. What is the ratio of the Number of teachers in Nepal in 2002 to that in 2009?
Give a very brief answer. 0.91. What is the ratio of the Number of teachers in Swaziland in 2002 to that in 2009?
Your response must be concise. 0.82. What is the ratio of the Number of teachers of China in 2002 to that in 2010?
Provide a succinct answer. 0.75. What is the ratio of the Number of teachers of Lesotho in 2002 to that in 2010?
Give a very brief answer. 0.69. What is the ratio of the Number of teachers of Nepal in 2002 to that in 2010?
Make the answer very short. 0.7. What is the ratio of the Number of teachers of Swaziland in 2002 to that in 2010?
Ensure brevity in your answer.  0.79. What is the ratio of the Number of teachers in China in 2002 to that in 2011?
Your response must be concise. 0.75. What is the ratio of the Number of teachers in Lesotho in 2002 to that in 2011?
Give a very brief answer. 0.67. What is the ratio of the Number of teachers of Nepal in 2002 to that in 2011?
Your answer should be very brief. 0.61. What is the ratio of the Number of teachers in Swaziland in 2002 to that in 2011?
Give a very brief answer. 0.73. What is the ratio of the Number of teachers in China in 2003 to that in 2009?
Offer a terse response. 0.8. What is the ratio of the Number of teachers of Lesotho in 2003 to that in 2009?
Your response must be concise. 0.73. What is the ratio of the Number of teachers of Nepal in 2003 to that in 2009?
Your answer should be very brief. 0.82. What is the ratio of the Number of teachers in Swaziland in 2003 to that in 2009?
Give a very brief answer. 0.78. What is the ratio of the Number of teachers of China in 2003 to that in 2010?
Your answer should be very brief. 0.8. What is the ratio of the Number of teachers in Lesotho in 2003 to that in 2010?
Ensure brevity in your answer.  0.71. What is the ratio of the Number of teachers of Nepal in 2003 to that in 2010?
Ensure brevity in your answer.  0.63. What is the ratio of the Number of teachers of Swaziland in 2003 to that in 2010?
Offer a terse response. 0.75. What is the ratio of the Number of teachers in China in 2003 to that in 2011?
Your answer should be very brief. 0.8. What is the ratio of the Number of teachers in Lesotho in 2003 to that in 2011?
Ensure brevity in your answer.  0.69. What is the ratio of the Number of teachers in Nepal in 2003 to that in 2011?
Ensure brevity in your answer.  0.55. What is the ratio of the Number of teachers in Swaziland in 2003 to that in 2011?
Your answer should be compact. 0.7. What is the ratio of the Number of teachers in China in 2009 to that in 2010?
Ensure brevity in your answer.  1. What is the ratio of the Number of teachers in Lesotho in 2009 to that in 2010?
Your answer should be compact. 0.97. What is the ratio of the Number of teachers of Nepal in 2009 to that in 2010?
Ensure brevity in your answer.  0.77. What is the ratio of the Number of teachers of Swaziland in 2009 to that in 2010?
Ensure brevity in your answer.  0.96. What is the ratio of the Number of teachers of Lesotho in 2009 to that in 2011?
Provide a short and direct response. 0.94. What is the ratio of the Number of teachers in Nepal in 2009 to that in 2011?
Your response must be concise. 0.67. What is the ratio of the Number of teachers of Swaziland in 2009 to that in 2011?
Keep it short and to the point. 0.9. What is the ratio of the Number of teachers of Lesotho in 2010 to that in 2011?
Offer a terse response. 0.97. What is the ratio of the Number of teachers in Nepal in 2010 to that in 2011?
Your answer should be compact. 0.88. What is the ratio of the Number of teachers of Swaziland in 2010 to that in 2011?
Give a very brief answer. 0.93. What is the difference between the highest and the second highest Number of teachers of China?
Offer a terse response. 1.41e+04. What is the difference between the highest and the second highest Number of teachers of Lesotho?
Provide a succinct answer. 143. What is the difference between the highest and the second highest Number of teachers in Nepal?
Offer a terse response. 1.17e+04. What is the difference between the highest and the second highest Number of teachers of Swaziland?
Your answer should be compact. 360. What is the difference between the highest and the lowest Number of teachers of China?
Keep it short and to the point. 1.86e+06. What is the difference between the highest and the lowest Number of teachers in Lesotho?
Ensure brevity in your answer.  1914. What is the difference between the highest and the lowest Number of teachers of Nepal?
Ensure brevity in your answer.  5.07e+04. What is the difference between the highest and the lowest Number of teachers of Swaziland?
Ensure brevity in your answer.  1763. 